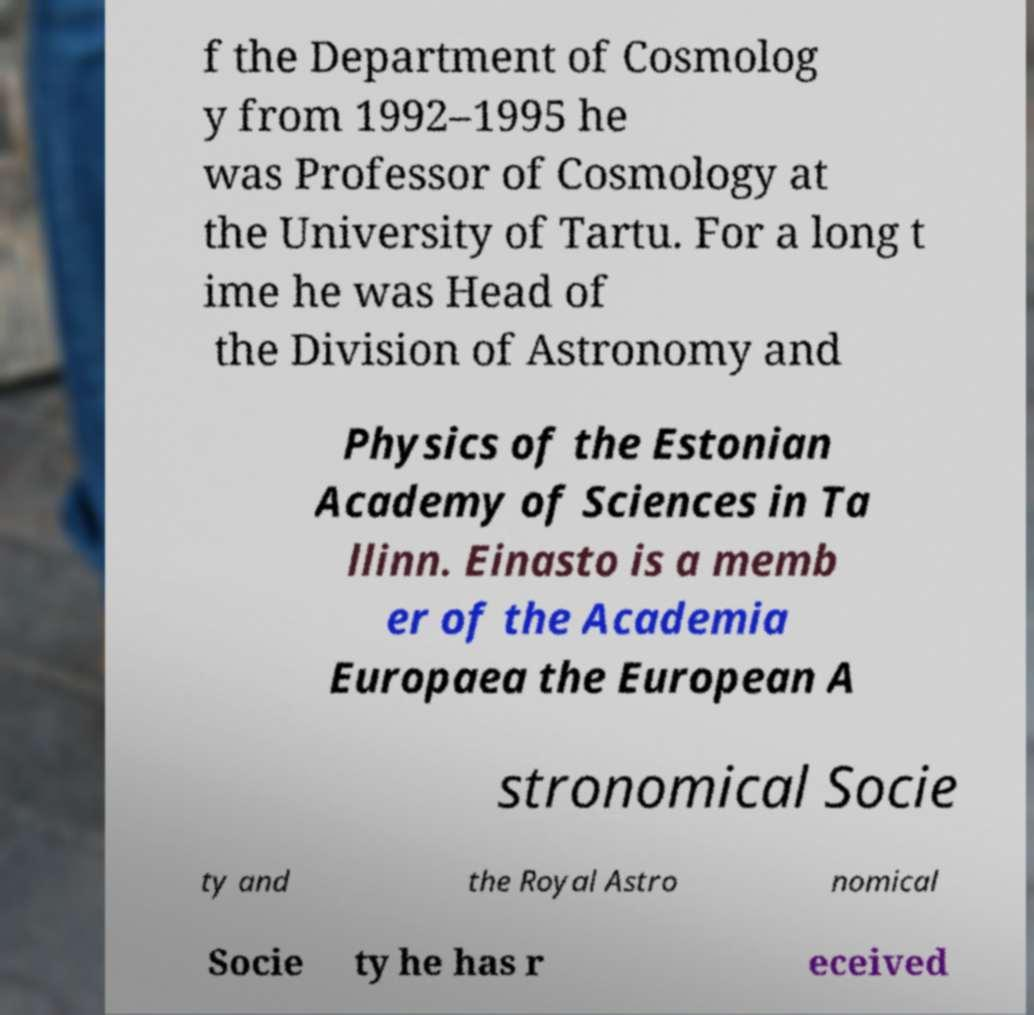Please read and relay the text visible in this image. What does it say? f the Department of Cosmolog y from 1992–1995 he was Professor of Cosmology at the University of Tartu. For a long t ime he was Head of the Division of Astronomy and Physics of the Estonian Academy of Sciences in Ta llinn. Einasto is a memb er of the Academia Europaea the European A stronomical Socie ty and the Royal Astro nomical Socie ty he has r eceived 